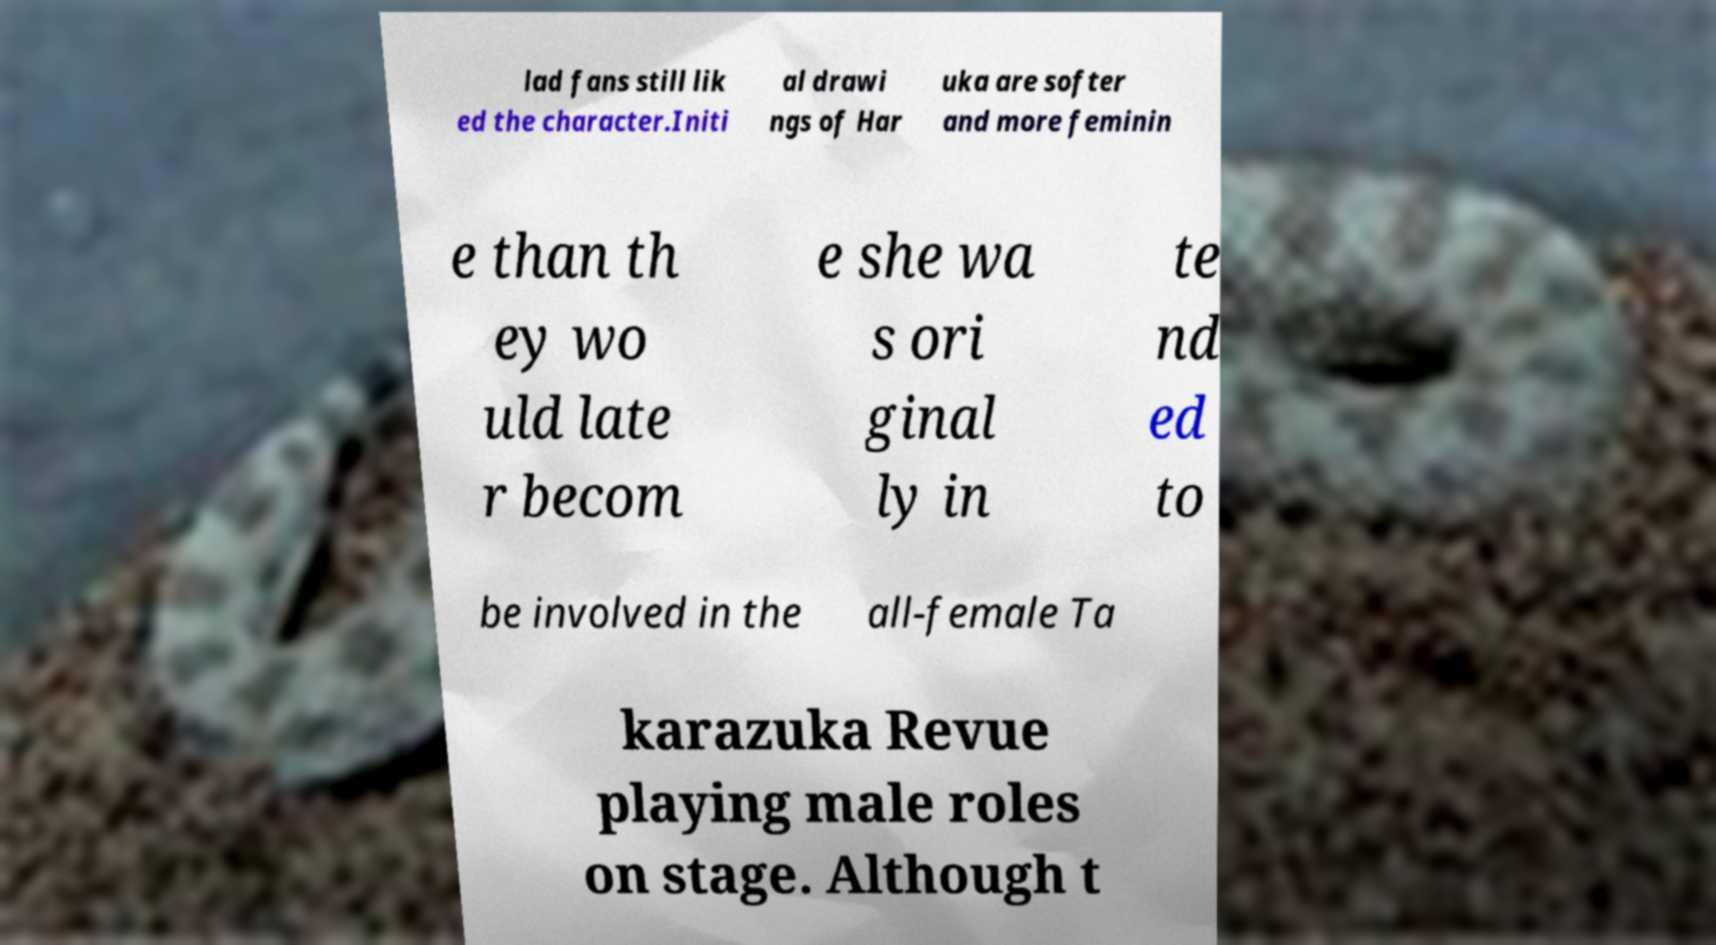I need the written content from this picture converted into text. Can you do that? lad fans still lik ed the character.Initi al drawi ngs of Har uka are softer and more feminin e than th ey wo uld late r becom e she wa s ori ginal ly in te nd ed to be involved in the all-female Ta karazuka Revue playing male roles on stage. Although t 